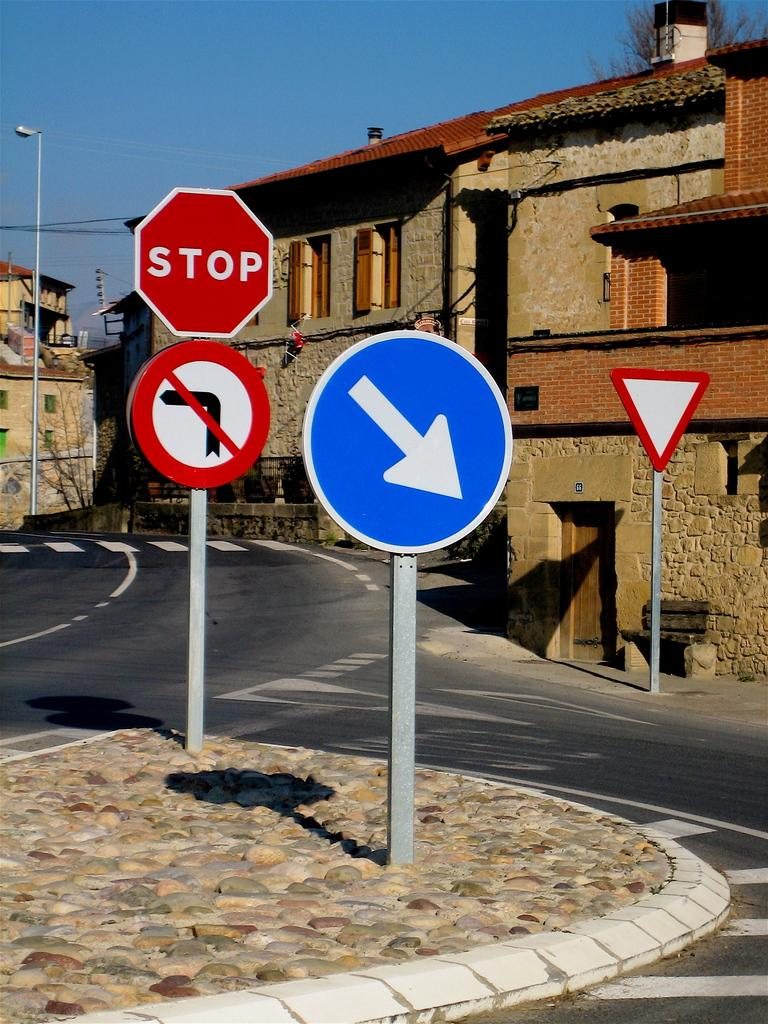<image>
Present a compact description of the photo's key features. Various traffic signs are on a curvy road including a stop sign. 